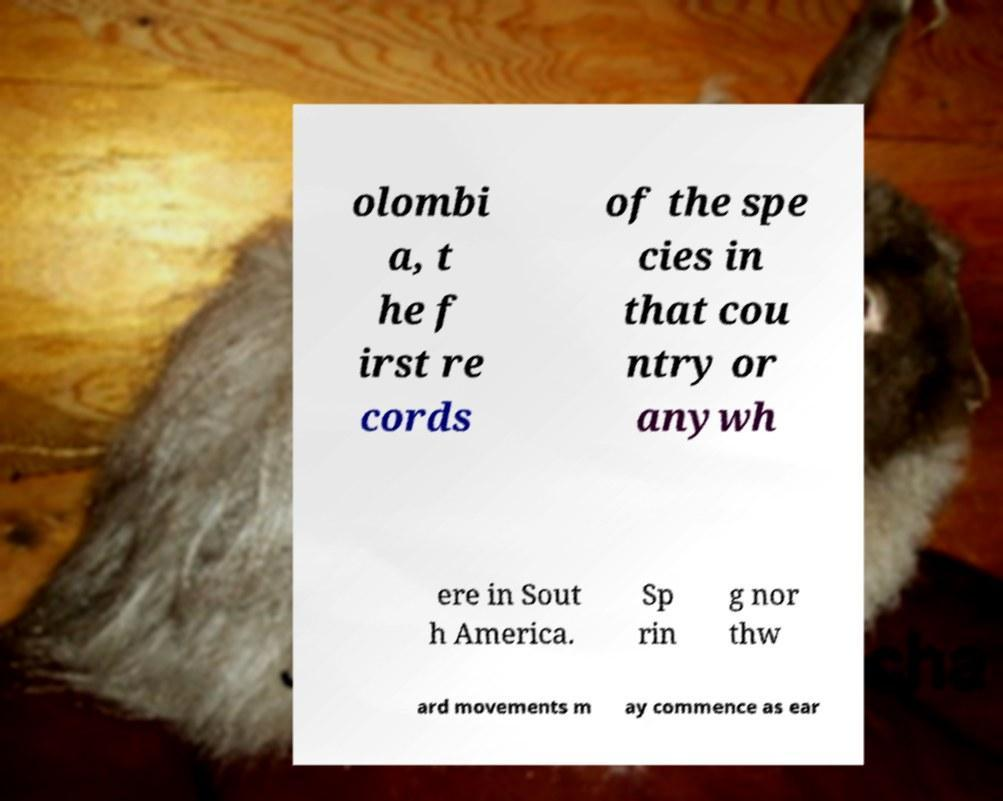There's text embedded in this image that I need extracted. Can you transcribe it verbatim? olombi a, t he f irst re cords of the spe cies in that cou ntry or anywh ere in Sout h America. Sp rin g nor thw ard movements m ay commence as ear 